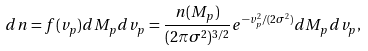<formula> <loc_0><loc_0><loc_500><loc_500>d n = f ( v _ { p } ) d M _ { p } d v _ { p } = \frac { n ( M _ { p } ) } { ( 2 \pi \sigma ^ { 2 } ) ^ { 3 / 2 } } e ^ { - v _ { p } ^ { 2 } / ( 2 \sigma ^ { 2 } ) } d M _ { p } d v _ { p } ,</formula> 